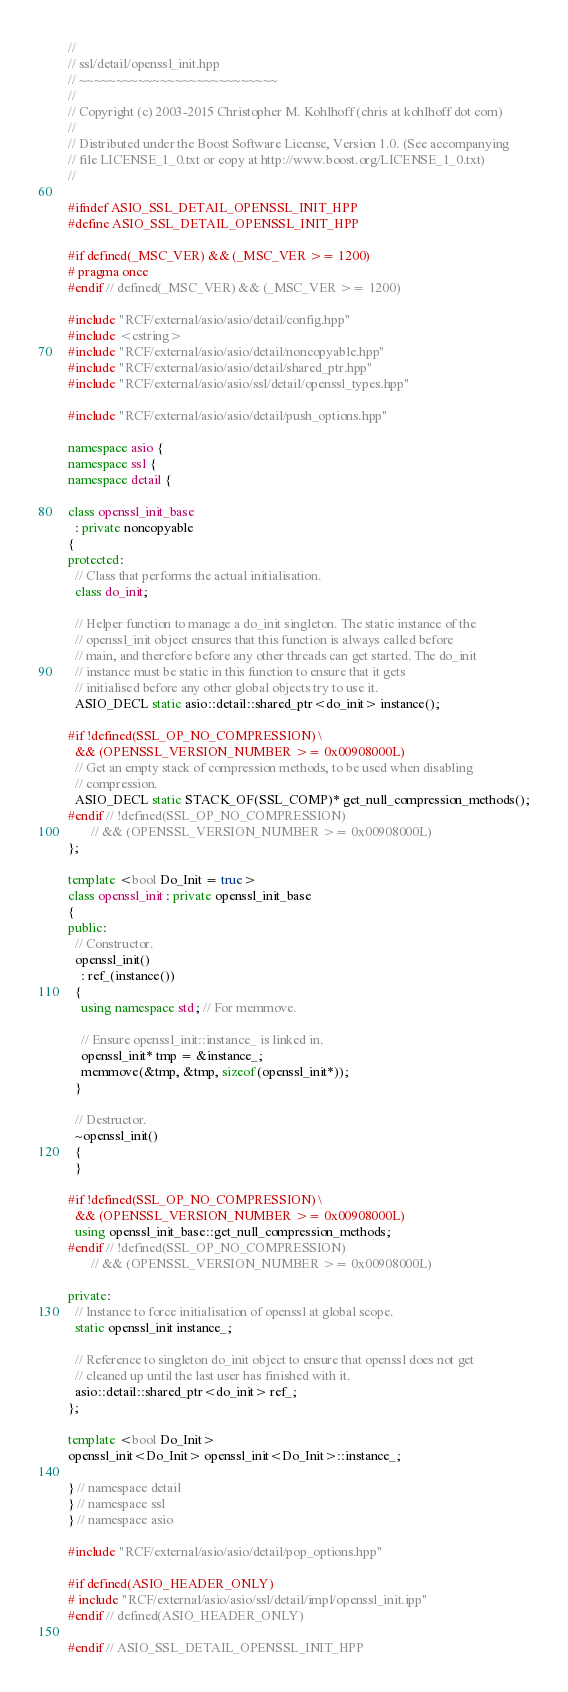<code> <loc_0><loc_0><loc_500><loc_500><_C++_>//
// ssl/detail/openssl_init.hpp
// ~~~~~~~~~~~~~~~~~~~~~~~~~~~
//
// Copyright (c) 2003-2015 Christopher M. Kohlhoff (chris at kohlhoff dot com)
//
// Distributed under the Boost Software License, Version 1.0. (See accompanying
// file LICENSE_1_0.txt or copy at http://www.boost.org/LICENSE_1_0.txt)
//

#ifndef ASIO_SSL_DETAIL_OPENSSL_INIT_HPP
#define ASIO_SSL_DETAIL_OPENSSL_INIT_HPP

#if defined(_MSC_VER) && (_MSC_VER >= 1200)
# pragma once
#endif // defined(_MSC_VER) && (_MSC_VER >= 1200)

#include "RCF/external/asio/asio/detail/config.hpp"
#include <cstring>
#include "RCF/external/asio/asio/detail/noncopyable.hpp"
#include "RCF/external/asio/asio/detail/shared_ptr.hpp"
#include "RCF/external/asio/asio/ssl/detail/openssl_types.hpp"

#include "RCF/external/asio/asio/detail/push_options.hpp"

namespace asio {
namespace ssl {
namespace detail {

class openssl_init_base
  : private noncopyable
{
protected:
  // Class that performs the actual initialisation.
  class do_init;

  // Helper function to manage a do_init singleton. The static instance of the
  // openssl_init object ensures that this function is always called before
  // main, and therefore before any other threads can get started. The do_init
  // instance must be static in this function to ensure that it gets
  // initialised before any other global objects try to use it.
  ASIO_DECL static asio::detail::shared_ptr<do_init> instance();

#if !defined(SSL_OP_NO_COMPRESSION) \
  && (OPENSSL_VERSION_NUMBER >= 0x00908000L)
  // Get an empty stack of compression methods, to be used when disabling
  // compression.
  ASIO_DECL static STACK_OF(SSL_COMP)* get_null_compression_methods();
#endif // !defined(SSL_OP_NO_COMPRESSION)
       // && (OPENSSL_VERSION_NUMBER >= 0x00908000L)
};

template <bool Do_Init = true>
class openssl_init : private openssl_init_base
{
public:
  // Constructor.
  openssl_init()
    : ref_(instance())
  {
    using namespace std; // For memmove.

    // Ensure openssl_init::instance_ is linked in.
    openssl_init* tmp = &instance_;
    memmove(&tmp, &tmp, sizeof(openssl_init*));
  }

  // Destructor.
  ~openssl_init()
  {
  }

#if !defined(SSL_OP_NO_COMPRESSION) \
  && (OPENSSL_VERSION_NUMBER >= 0x00908000L)
  using openssl_init_base::get_null_compression_methods;
#endif // !defined(SSL_OP_NO_COMPRESSION)
       // && (OPENSSL_VERSION_NUMBER >= 0x00908000L)

private:
  // Instance to force initialisation of openssl at global scope.
  static openssl_init instance_;

  // Reference to singleton do_init object to ensure that openssl does not get
  // cleaned up until the last user has finished with it.
  asio::detail::shared_ptr<do_init> ref_;
};

template <bool Do_Init>
openssl_init<Do_Init> openssl_init<Do_Init>::instance_;

} // namespace detail
} // namespace ssl
} // namespace asio

#include "RCF/external/asio/asio/detail/pop_options.hpp"

#if defined(ASIO_HEADER_ONLY)
# include "RCF/external/asio/asio/ssl/detail/impl/openssl_init.ipp"
#endif // defined(ASIO_HEADER_ONLY)

#endif // ASIO_SSL_DETAIL_OPENSSL_INIT_HPP
</code> 